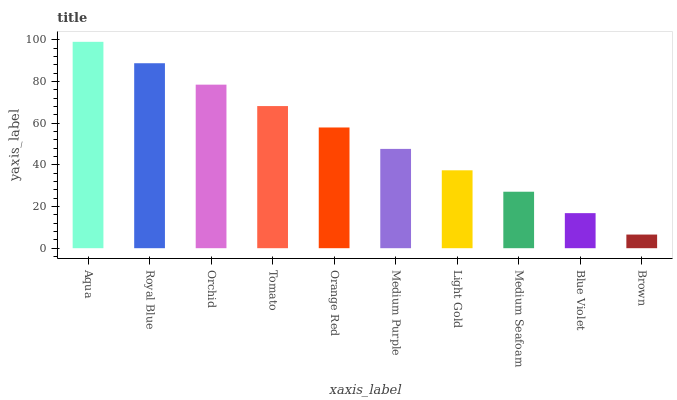Is Brown the minimum?
Answer yes or no. Yes. Is Aqua the maximum?
Answer yes or no. Yes. Is Royal Blue the minimum?
Answer yes or no. No. Is Royal Blue the maximum?
Answer yes or no. No. Is Aqua greater than Royal Blue?
Answer yes or no. Yes. Is Royal Blue less than Aqua?
Answer yes or no. Yes. Is Royal Blue greater than Aqua?
Answer yes or no. No. Is Aqua less than Royal Blue?
Answer yes or no. No. Is Orange Red the high median?
Answer yes or no. Yes. Is Medium Purple the low median?
Answer yes or no. Yes. Is Medium Seafoam the high median?
Answer yes or no. No. Is Orange Red the low median?
Answer yes or no. No. 